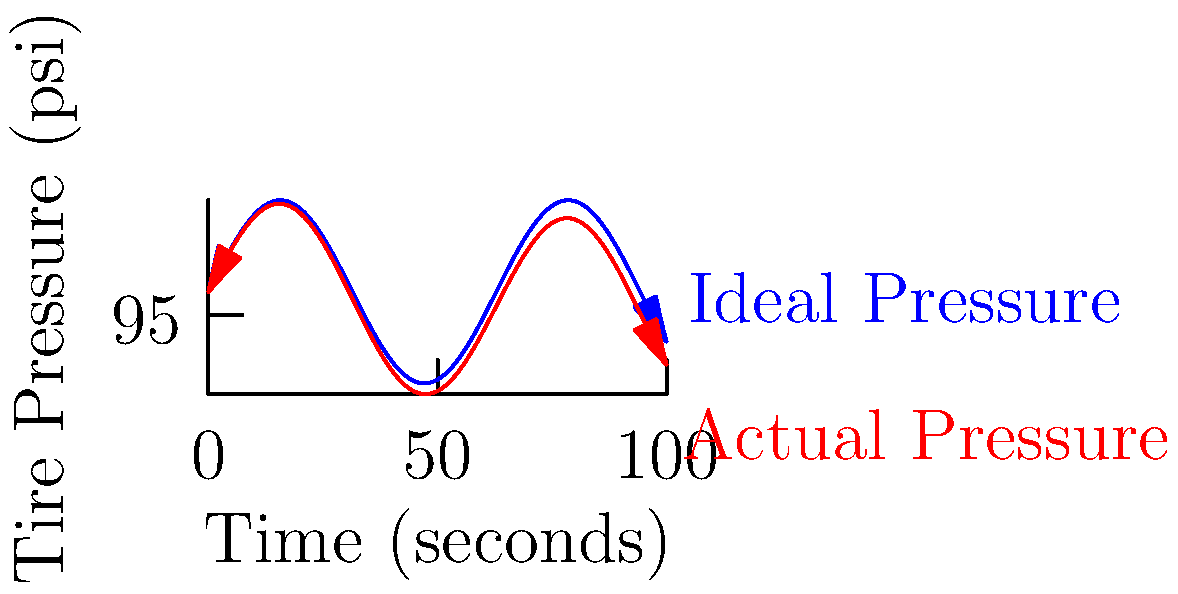During a high-speed race, a tire's pressure fluctuates due to various factors. The ideal tire pressure (in psi) as a function of time $t$ (in seconds) is given by $P_i(t) = 100 + 20\sin(t/10)$. However, due to a small leak, the actual pressure $P_a(t)$ decreases linearly at a rate of 0.05 psi per second. If the race lasts for 100 seconds, find the maximum difference between the ideal and actual tire pressure during the race. 1) The actual pressure function is:
   $P_a(t) = P_i(t) - 0.05t = 100 + 20\sin(t/10) - 0.05t$

2) The difference function is:
   $D(t) = P_i(t) - P_a(t) = 0.05t$

3) To find the maximum difference, we need to find the maximum value of $D(t)$ in the interval $[0, 100]$.

4) Since $D(t)$ is a linear function with a positive slope, its maximum value will occur at the end of the interval, i.e., at $t = 100$.

5) Calculate the maximum difference:
   $D(100) = 0.05 * 100 = 5$ psi

Therefore, the maximum difference between the ideal and actual tire pressure during the 100-second race is 5 psi.
Answer: 5 psi 